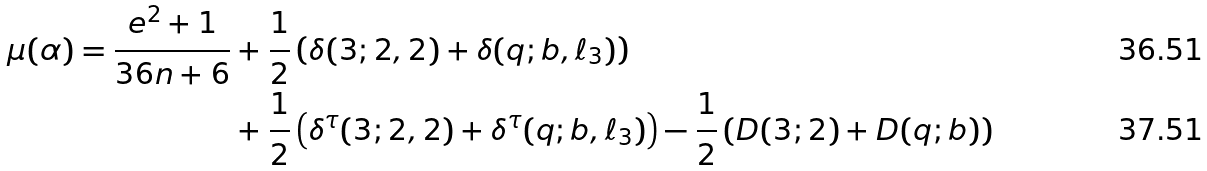Convert formula to latex. <formula><loc_0><loc_0><loc_500><loc_500>\mu ( \alpha ) = \frac { e ^ { 2 } + 1 } { 3 6 n + 6 } & + \frac { 1 } { 2 } \left ( \delta ( 3 ; 2 , 2 ) + \delta ( q ; b , \ell _ { 3 } ) \right ) \\ & + \frac { 1 } { 2 } \left ( \delta ^ { \tau } ( 3 ; 2 , 2 ) + \delta ^ { \tau } ( q ; b , \ell _ { 3 } ) \right ) - \frac { 1 } { 2 } \left ( D ( 3 ; 2 ) + D ( q ; b ) \right )</formula> 